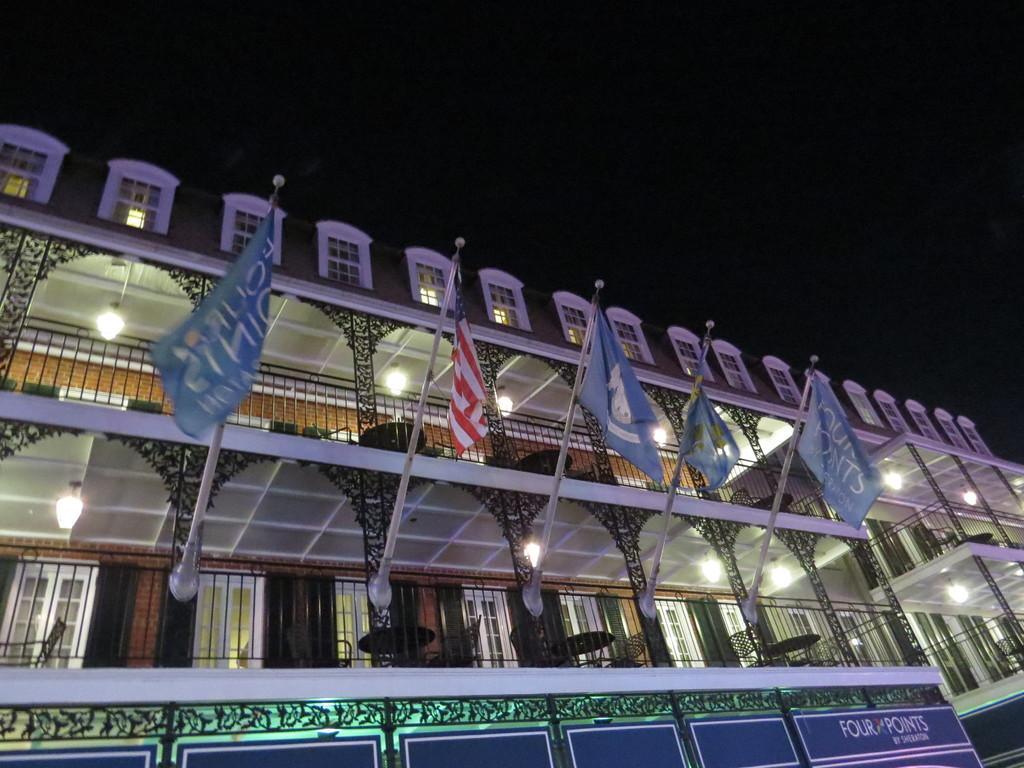In one or two sentences, can you explain what this image depicts? In this image there is a building for that building there are flags, in that building there are tables, chairs and lights. 